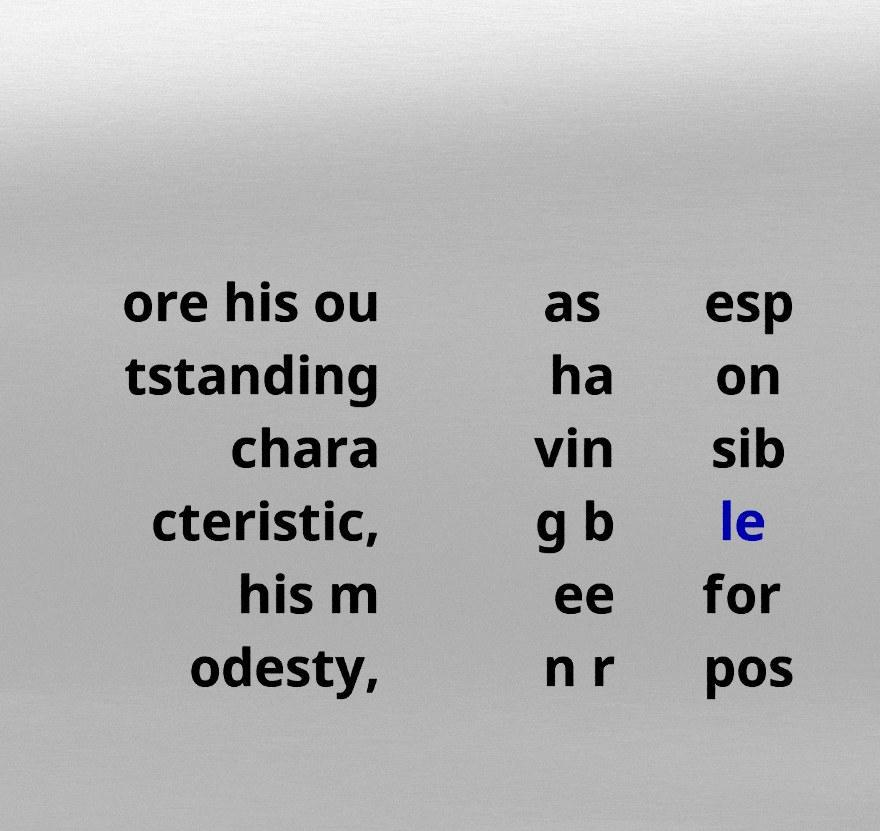There's text embedded in this image that I need extracted. Can you transcribe it verbatim? ore his ou tstanding chara cteristic, his m odesty, as ha vin g b ee n r esp on sib le for pos 